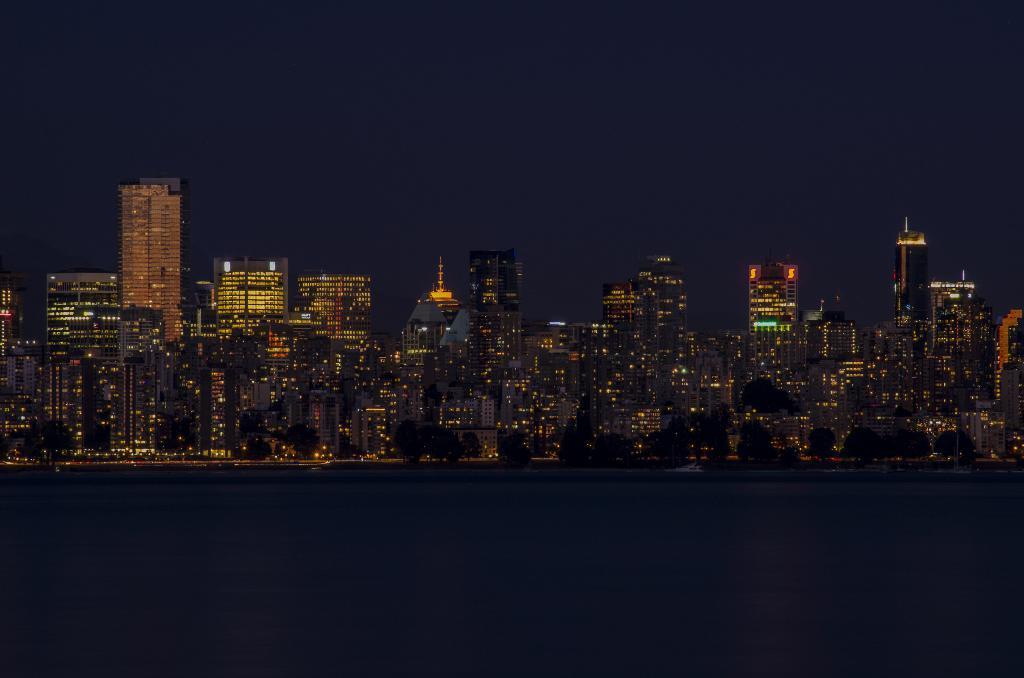Can you describe this image briefly? In this image we can see a group of buildings with lights and some trees. We can also see a large water body and the sky. 